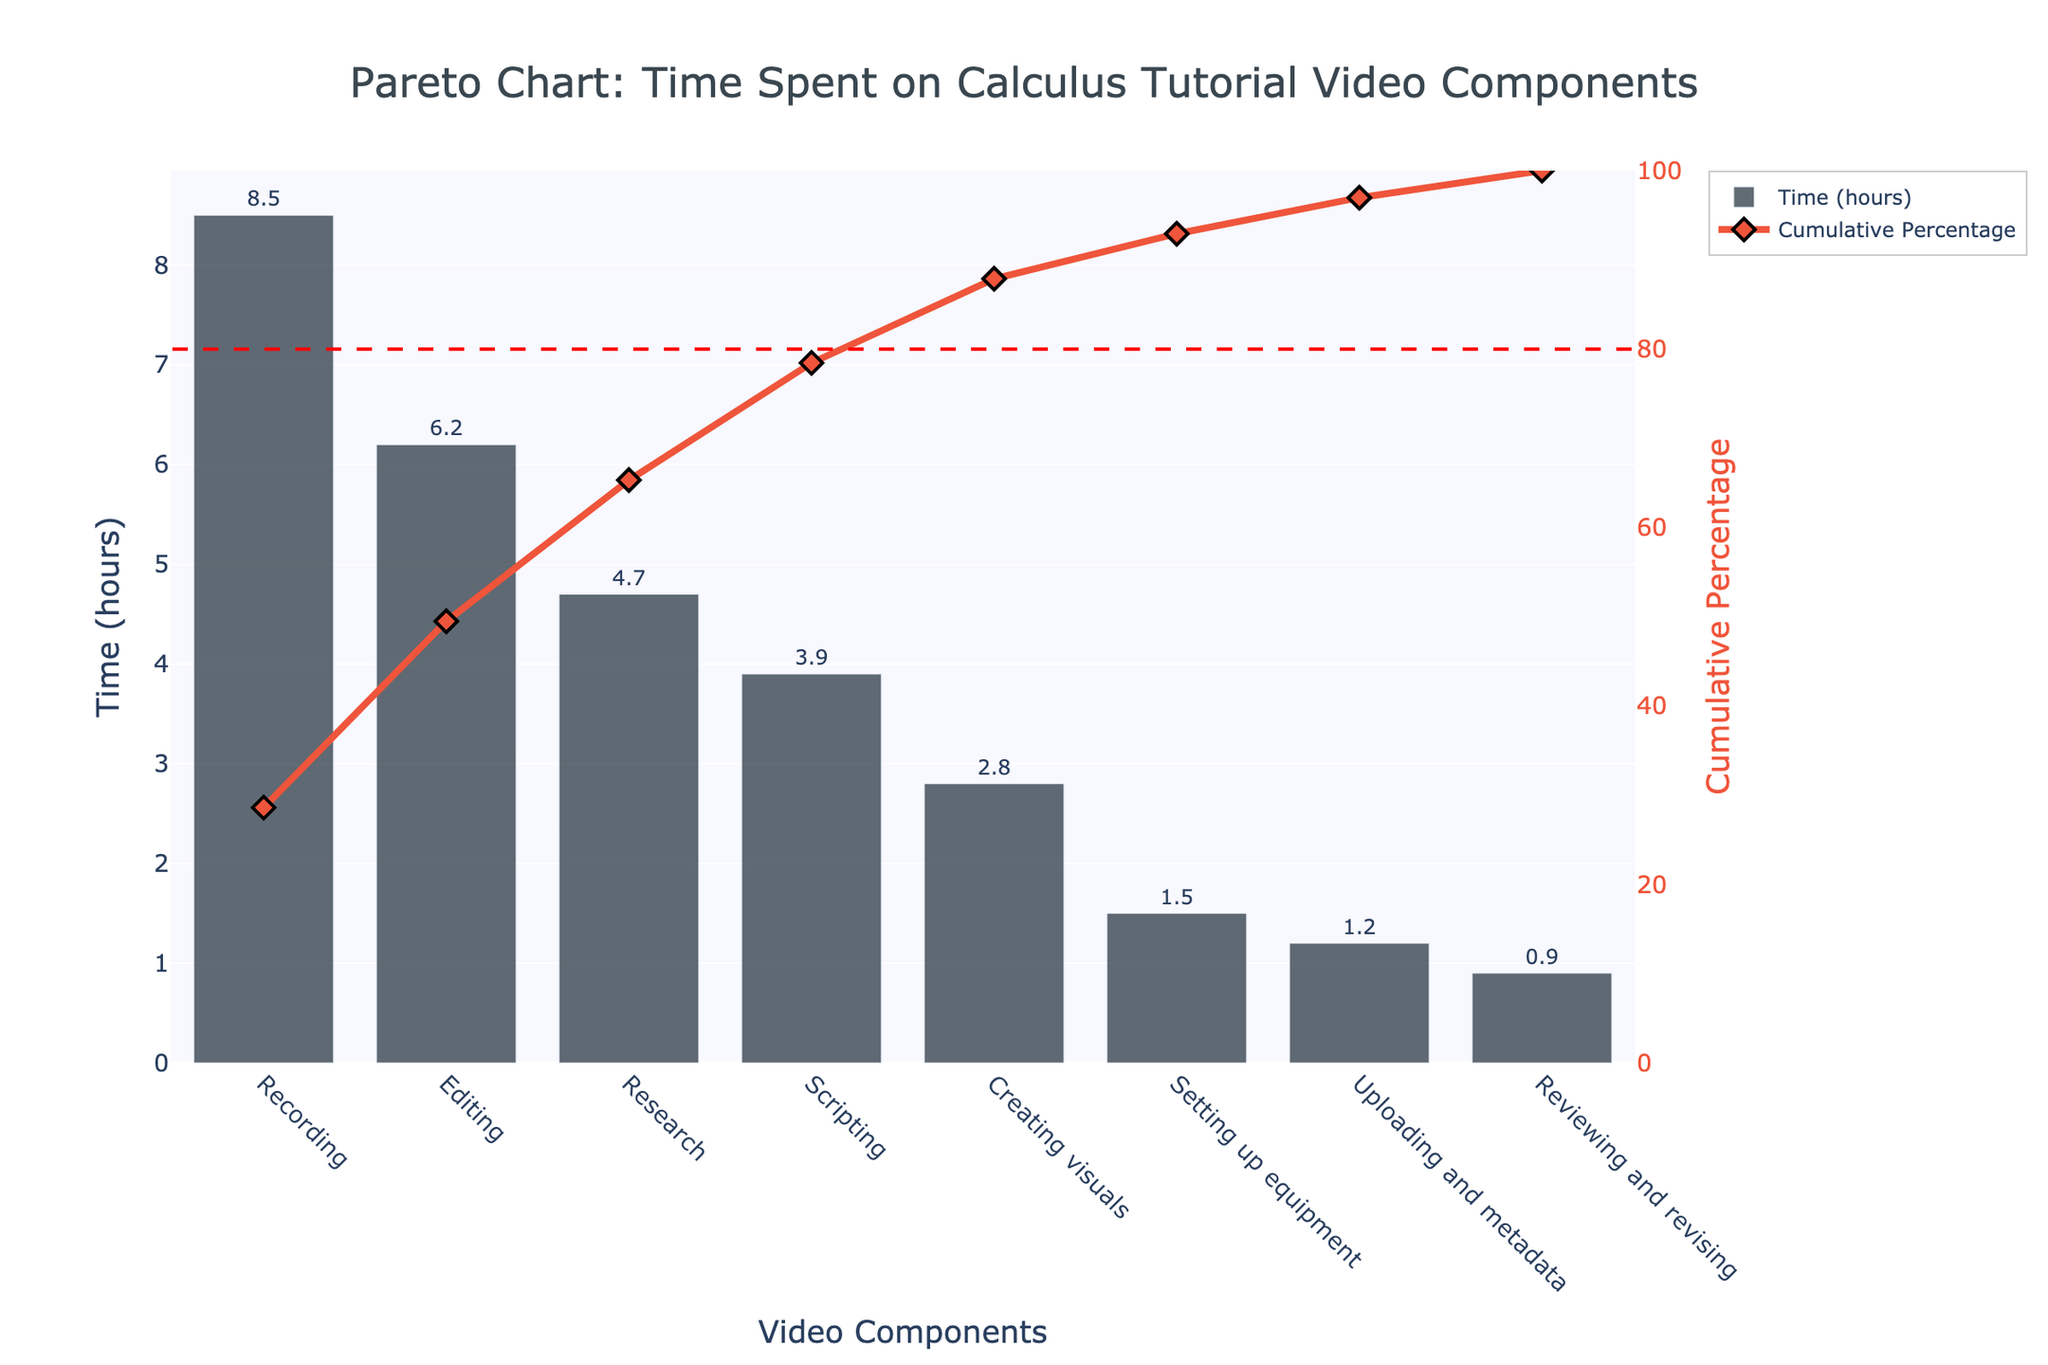What is the title of the figure? The title is typically positioned at the top of the figure and provides a concise summary of what the figure represents. In this case, it reads "Pareto Chart: Time Spent on Calculus Tutorial Video Components."
Answer: Pareto Chart: Time Spent on Calculus Tutorial Video Components Which video component took the most time? The bar representing the component that took the most time will be the tallest bar on the chart. Here, "Recording" with 8.5 hours is the tallest bar.
Answer: Recording What is the cumulative percentage of time after editing is included? To find the cumulative percentage at "Editing," sum the time for "Recording" and "Editing" and calculate its percentage of the total time. The cumulative percentage values should be plotted as a line, and for "Editing," this value is 63.3%.
Answer: 63.3% Which components together account for approximately 80% of the total time? To identify this, add the times of components in descending order until the cumulative percentage is around 80%. The components "Recording," "Editing," "Research," and "Scripting" together account for 83.7%, crossing the 80% mark.
Answer: Recording, Editing, Research, and Scripting What does the red dashed line at 80% represent? The red dashed line at 80% is a common feature in Pareto charts indicating the threshold where 80% of the effects come from 20% of the causes. Here, it visually shows where 80% of the time has been spent on the components.
Answer: It represents the 80% cumulative percentage threshold Which components took less than 2 hours each? Look for the bars with height less than 2 on the y-axis. These are "Setting up equipment," "Uploading and metadata," and "Reviewing and revising," with 1.5, 1.2, and 0.9 hours respectively.
Answer: Setting up equipment, Uploading and metadata, Reviewing and revising What proportion of the total time was spent on "Creating visuals"? To find this, divide the time spent on "Creating visuals" by the total time, then multiply by 100 for a percentage. The time for "Creating visuals" is 2.8 hours out of a total sum of 29.7 hours (sum all times). That calculation is (2.8/29.7) * 100.
Answer: Approximately 9.4% How does the time spent on "Research" compare to "Editing"? Look at their respective bar heights and times. "Research" took 4.7 hours and "Editing" took 6.2 hours, making "Editing" take 1.5 more hours than "Research."
Answer: Editing took 1.5 more hours than Research Do more than half of the total hours come from just two of the components? Sum the times of the top two components "Recording" and "Editing" (8.5 + 6.2 = 14.7) and compare it to half of the total time (0.5 * 29.7 = 14.85). 14.7 hours is just slightly less than half the total.
Answer: No What is the second highest component in terms of time spent? After "Recording," the next tallest bar is "Editing," which took 6.2 hours.
Answer: Editing 